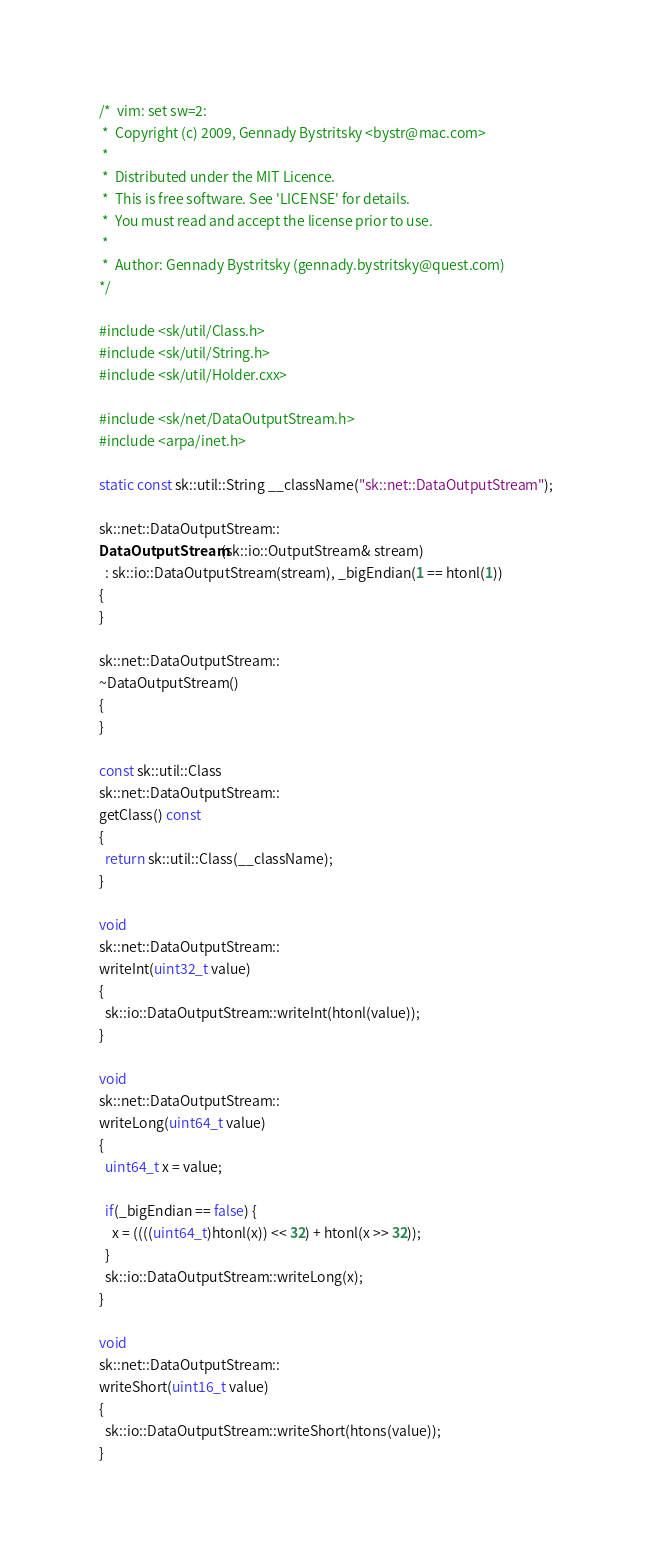<code> <loc_0><loc_0><loc_500><loc_500><_C++_>/*  vim: set sw=2:
 *  Copyright (c) 2009, Gennady Bystritsky <bystr@mac.com>
 *
 *  Distributed under the MIT Licence.
 *  This is free software. See 'LICENSE' for details.
 *  You must read and accept the license prior to use.
 *
 *  Author: Gennady Bystritsky (gennady.bystritsky@quest.com)
*/

#include <sk/util/Class.h>
#include <sk/util/String.h>
#include <sk/util/Holder.cxx>

#include <sk/net/DataOutputStream.h>
#include <arpa/inet.h>

static const sk::util::String __className("sk::net::DataOutputStream");

sk::net::DataOutputStream::
DataOutputStream(sk::io::OutputStream& stream)
  : sk::io::DataOutputStream(stream), _bigEndian(1 == htonl(1))
{
}

sk::net::DataOutputStream::
~DataOutputStream()
{
}

const sk::util::Class
sk::net::DataOutputStream::
getClass() const
{
  return sk::util::Class(__className);
}

void
sk::net::DataOutputStream::
writeInt(uint32_t value)
{
  sk::io::DataOutputStream::writeInt(htonl(value));
}

void
sk::net::DataOutputStream::
writeLong(uint64_t value)
{
  uint64_t x = value;

  if(_bigEndian == false) {
    x = ((((uint64_t)htonl(x)) << 32) + htonl(x >> 32));
  }
  sk::io::DataOutputStream::writeLong(x);
}

void
sk::net::DataOutputStream::
writeShort(uint16_t value)
{
  sk::io::DataOutputStream::writeShort(htons(value));
}
</code> 